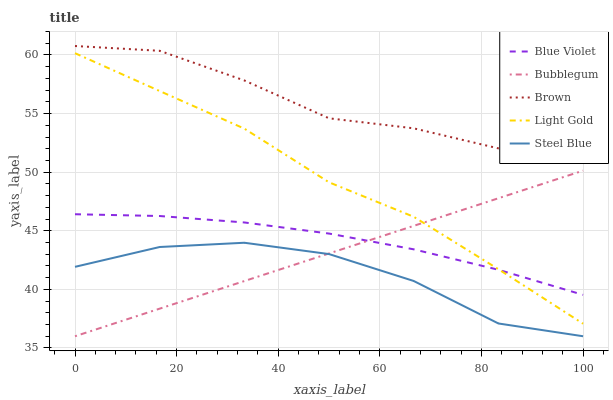Does Steel Blue have the minimum area under the curve?
Answer yes or no. Yes. Does Brown have the maximum area under the curve?
Answer yes or no. Yes. Does Light Gold have the minimum area under the curve?
Answer yes or no. No. Does Light Gold have the maximum area under the curve?
Answer yes or no. No. Is Bubblegum the smoothest?
Answer yes or no. Yes. Is Steel Blue the roughest?
Answer yes or no. Yes. Is Light Gold the smoothest?
Answer yes or no. No. Is Light Gold the roughest?
Answer yes or no. No. Does Bubblegum have the lowest value?
Answer yes or no. Yes. Does Light Gold have the lowest value?
Answer yes or no. No. Does Brown have the highest value?
Answer yes or no. Yes. Does Light Gold have the highest value?
Answer yes or no. No. Is Bubblegum less than Brown?
Answer yes or no. Yes. Is Brown greater than Steel Blue?
Answer yes or no. Yes. Does Steel Blue intersect Bubblegum?
Answer yes or no. Yes. Is Steel Blue less than Bubblegum?
Answer yes or no. No. Is Steel Blue greater than Bubblegum?
Answer yes or no. No. Does Bubblegum intersect Brown?
Answer yes or no. No. 